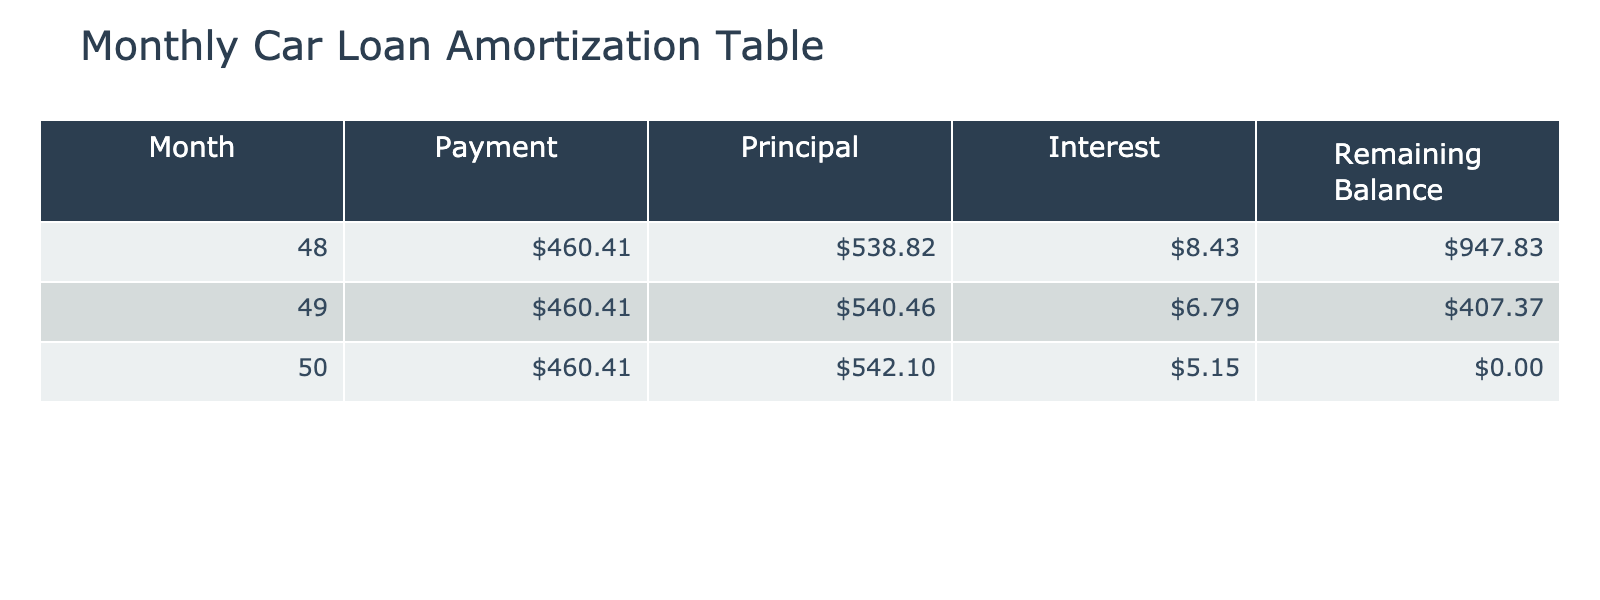What is the monthly payment amount for the car loan? The monthly payment is indicated in the table under the "Payment" column. Referring to any row in the table, the payment amount is consistently shown as 460.41.
Answer: 460.41 What is the interest for month 49? Looking at row 49 in the table, the interest for that month is directly listed under the "Interest" column as 6.79.
Answer: 6.79 How much principal is paid off in month 48? In the table, month 48 shows a principal payment amount of 538.82 under the "Principal" column.
Answer: 538.82 What is the remaining balance after the payment in month 50? By referring to the "Remaining Balance" column for month 50, the remaining balance after the payment is shown as 0.00.
Answer: 0.00 What is the total interest paid in months 48, 49, and 50 combined? To find the total interest paid, we sum the interest amounts from the three months: 8.43 (month 48) + 6.79 (month 49) + 5.15 (month 50) = 20.37.
Answer: 20.37 Is the total principal paid in month 49 greater than the interest paid that month? For month 49, the principal payment is 540.46 and the interest is 6.79. Since 540.46 is greater than 6.79, the statement is true.
Answer: Yes What is the average monthly principal paid over the last three months (months 48 to 50)? To find the average, we sum the principal payments for the last three months: 538.82 (month 48) + 540.46 (month 49) + 542.10 (month 50) = 1621.38. Then we divide by 3: 1621.38 / 3 = 540.46.
Answer: 540.46 How much principal is left to pay after month 48? In month 49, the remaining balance is listed as 407.37, which indicates that 947.83 (remaining balance of month 48) minus 540.46 (principal paid in month 49) gives the remaining balance after month 48.
Answer: 947.83 Was there any month where the principal payment dropped below 500? Examining the rows for all months provided, each principal amount (538.82, 540.46, 542.10) is greater than 500. Thus, there were no months where the principal payment was below 500.
Answer: No 